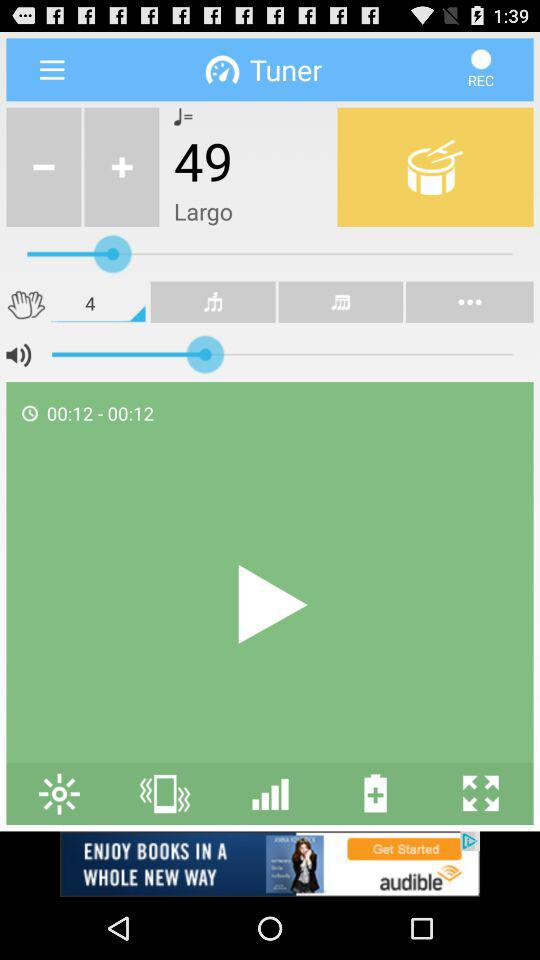What is the total duration of the song? The total duration of the song is 00:12. 